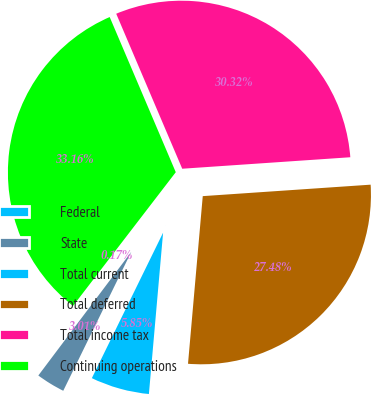<chart> <loc_0><loc_0><loc_500><loc_500><pie_chart><fcel>Federal<fcel>State<fcel>Total current<fcel>Total deferred<fcel>Total income tax<fcel>Continuing operations<nl><fcel>0.17%<fcel>3.01%<fcel>5.85%<fcel>27.48%<fcel>30.32%<fcel>33.16%<nl></chart> 